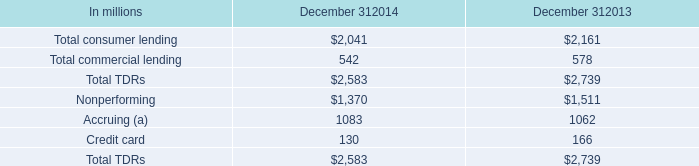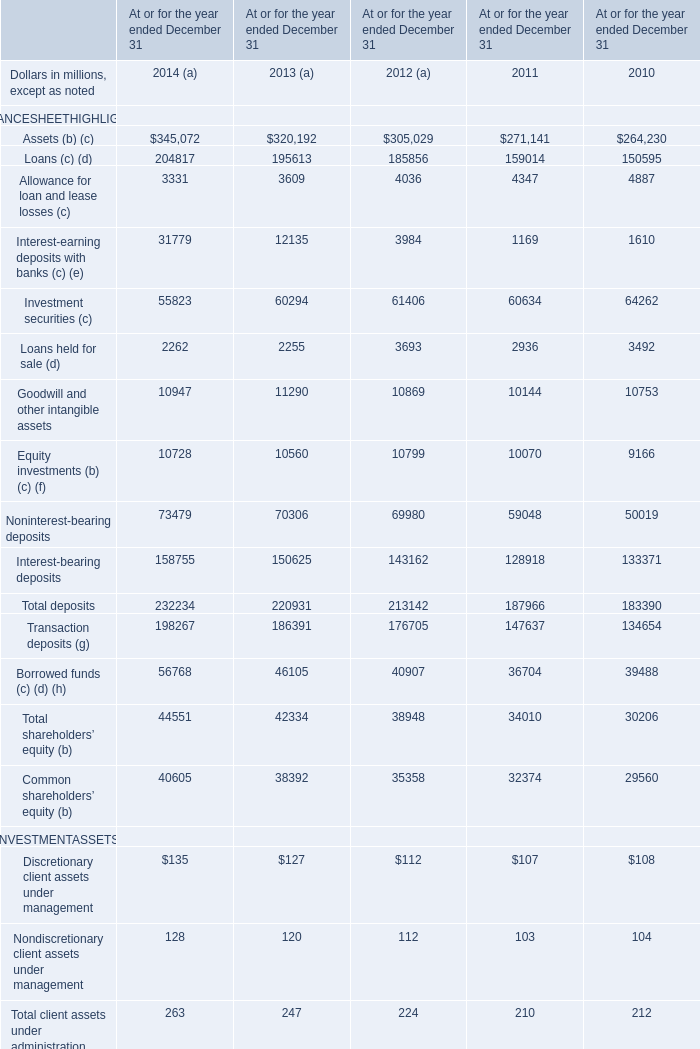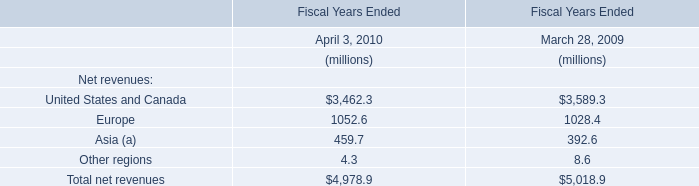Does the average value ofAssets (b) (c) in 2014 greater than that in 2013? 
Answer: yes. 